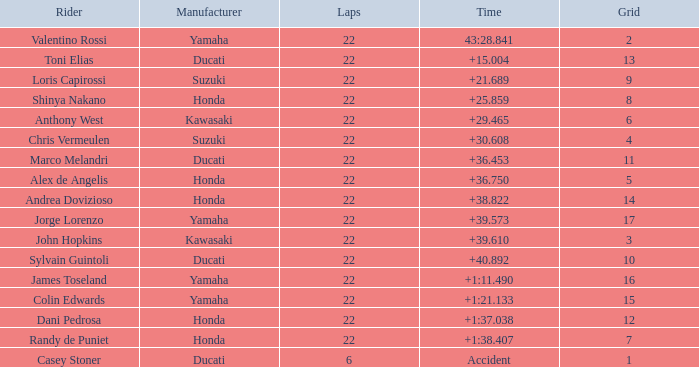What laps did Honda do with a time of +1:38.407? 22.0. 